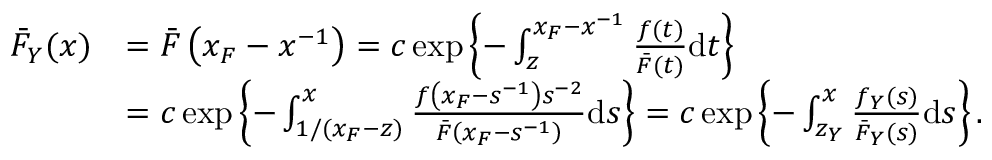<formula> <loc_0><loc_0><loc_500><loc_500>\begin{array} { r l } { \bar { F } _ { Y } ( x ) } & { = \bar { F } \left ( x _ { F } - x ^ { - 1 } \right ) = c \exp \left \{ - \int _ { z } ^ { x _ { F } - x ^ { - 1 } } \frac { f ( t ) } { \bar { F } ( t ) } d t \right \} } \\ & { = c \exp \left \{ - \int _ { 1 / ( x _ { F } - z ) } ^ { x } \frac { f \left ( x _ { F } - s ^ { - 1 } \right ) s ^ { - 2 } } { \bar { F } \left ( x _ { F } - s ^ { - 1 } \right ) } d s \right \} = c \exp \left \{ - \int _ { z _ { Y } } ^ { x } \frac { f _ { Y } ( s ) } { \bar { F } _ { Y } ( s ) } d s \right \} . } \end{array}</formula> 